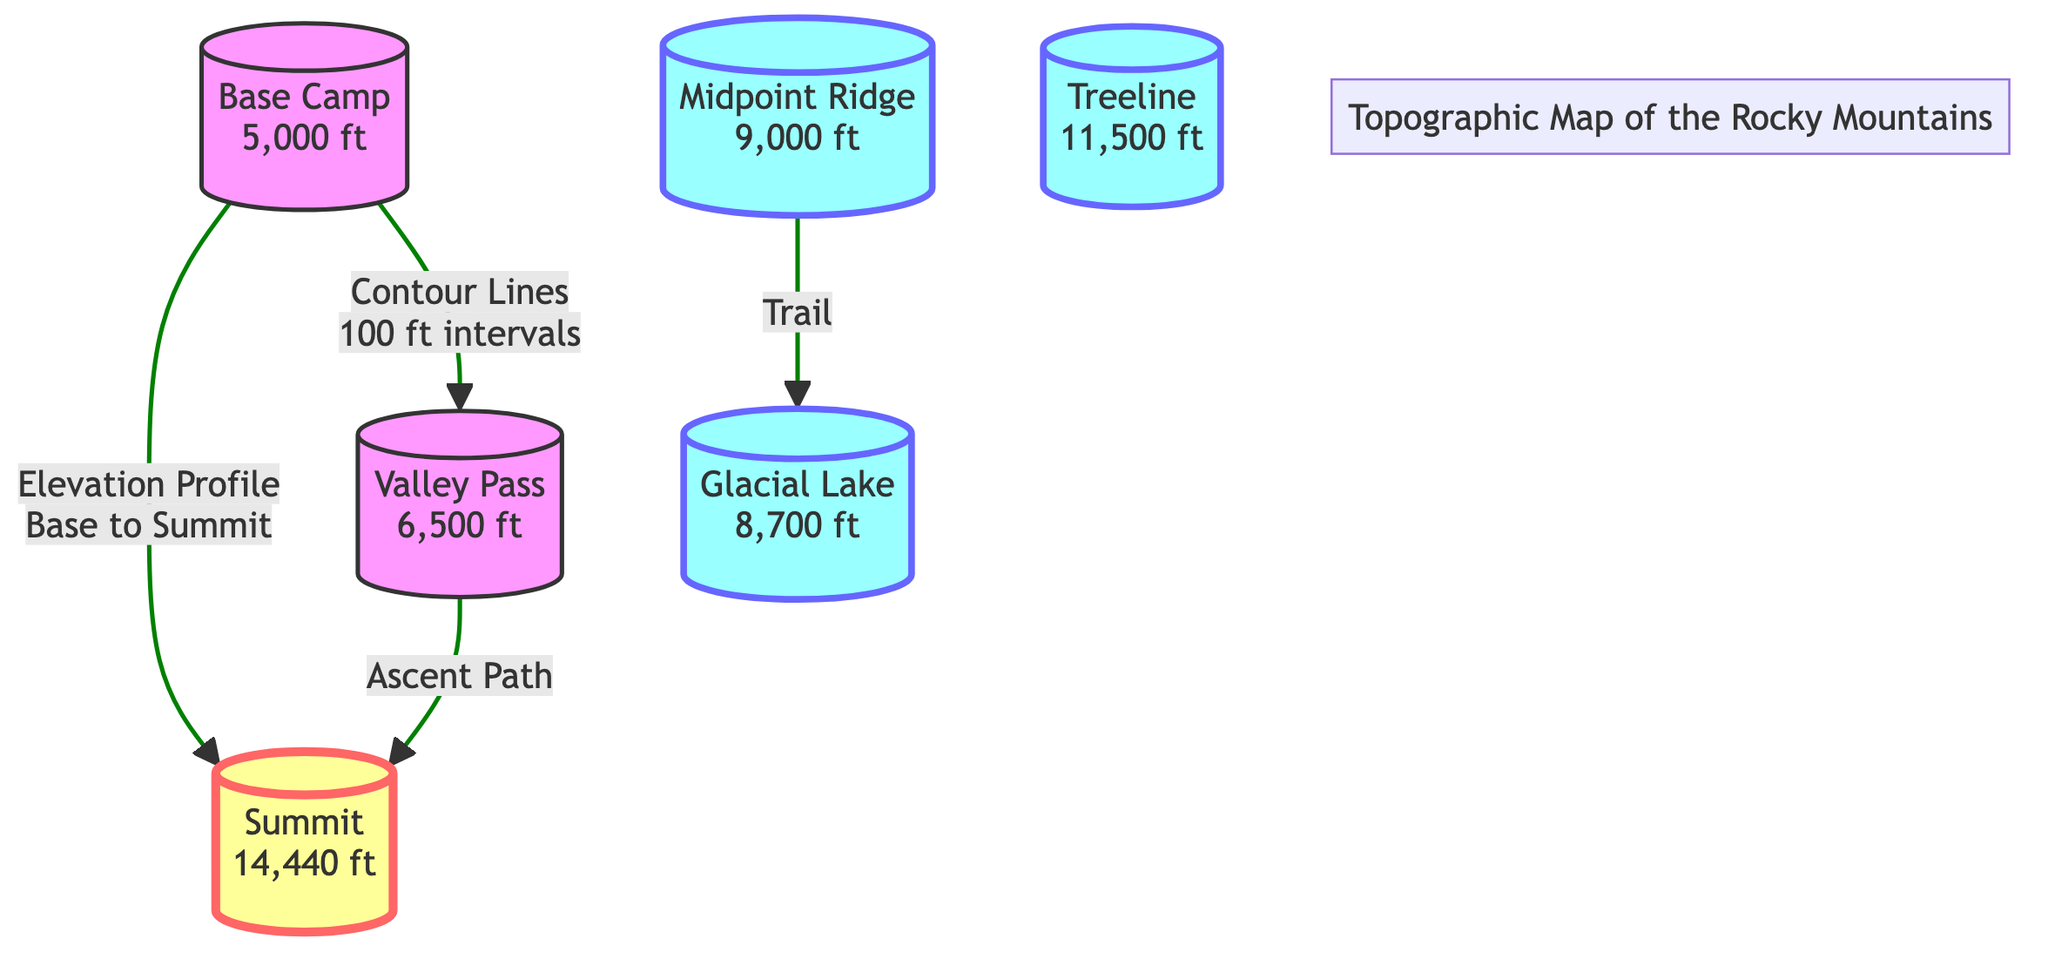What is the elevation of the Summit? The diagram directly labels the Summit node with an elevation of 14,440 ft.
Answer: 14,440 ft What is the elevation of the Base Camp? The Base Camp node in the diagram clearly states its elevation as 5,000 ft.
Answer: 5,000 ft How many nodes are present in this diagram? Counting the nodes in the diagram reveals there are six distinct points: Base Camp, Summit, Midpoint Ridge, Treeline, Valley Pass, and Glacial Lake, totaling six nodes.
Answer: 6 What connects the Base Camp to the Summit? The diagram shows an "Elevation Profile" connecting the Base Camp to the Summit, indicating the path of elevation.
Answer: Elevation Profile Which node has a higher elevation, Treeline or Midpoint Ridge? A comparison of the elevations in the diagram indicates the Treeline is at 11,500 ft, while the Midpoint Ridge is at 9,000 ft. Therefore, Treeline has a higher elevation.
Answer: Treeline What path leads from Valley Pass to Summit? The diagram indicates that the path leading from the Valley Pass (6,500 ft) to the Summit (14,440 ft) is labeled "Ascent Path."
Answer: Ascent Path What is the elevation of the Glacial Lake? The Glacial Lake node in the diagram is labeled with an elevation of 8,700 ft.
Answer: 8,700 ft What type of information do the contour lines represent? The contour lines in the diagram represent elevation changes at 100 ft intervals, reflecting the changes in terrain elevation.
Answer: Elevation changes Which two nodes are connected by the Trail? The diagram indicates that the Trail connects the Midpoint Ridge to the Glacial Lake, showing a relationship between these two points.
Answer: Midpoint Ridge and Glacial Lake What does the color coding indicate for the Base Camp? The diagram uses a specific color coding scheme, identifying the Base Camp with a pinkish fill (baseStyle), which differentiates it from the Summit and other elevation nodes.
Answer: pinkish fill 